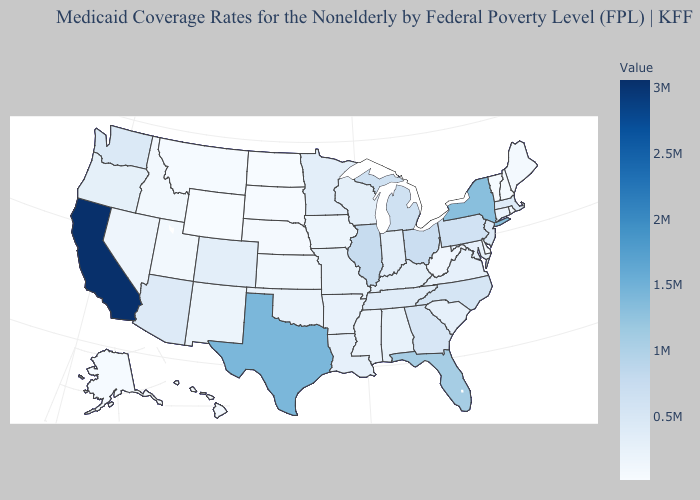Does California have the highest value in the USA?
Keep it brief. Yes. Among the states that border Wyoming , does South Dakota have the lowest value?
Keep it brief. Yes. 